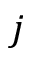Convert formula to latex. <formula><loc_0><loc_0><loc_500><loc_500>j</formula> 